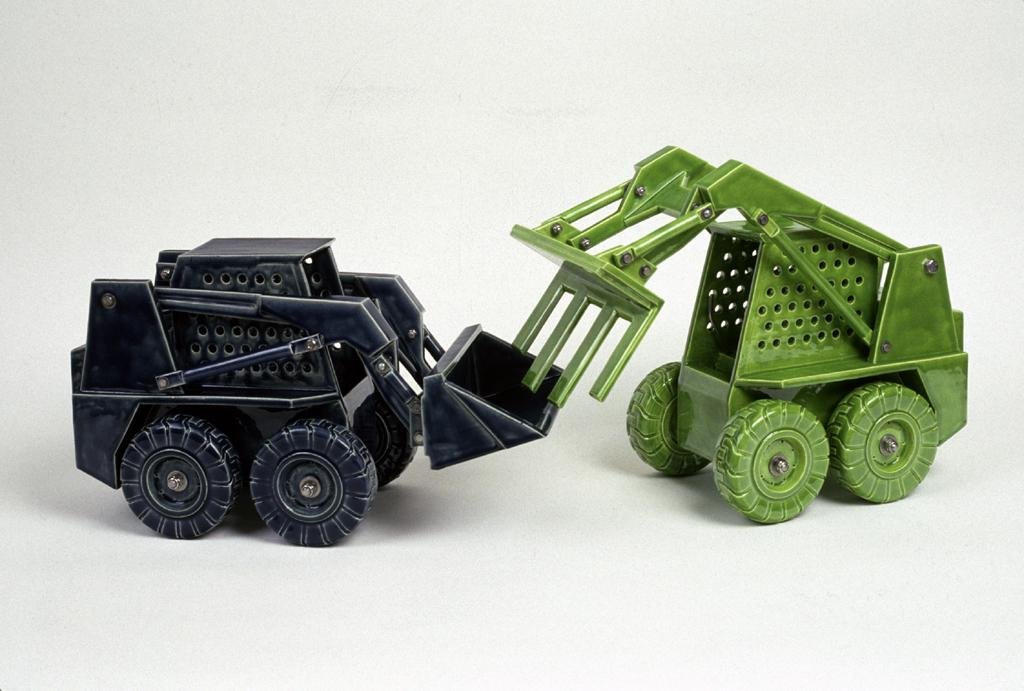What type of objects are present in the image? There are toy vehicles in the image. Can you describe the colors of the toy vehicles? The toy vehicles have green and black colors. What is the color of the background in the image? The background of the image is white. What type of wine is being served in the image? There is no wine present in the image; it features toy vehicles with green and black colors against a white background. 